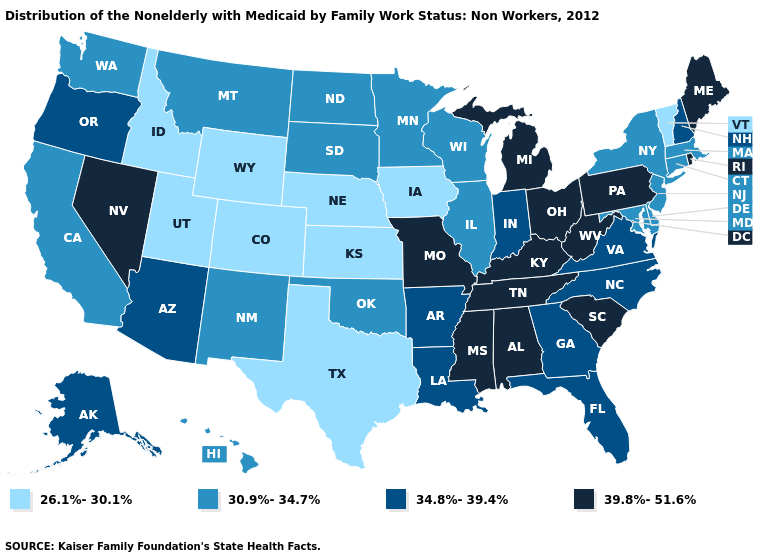Among the states that border Mississippi , which have the lowest value?
Short answer required. Arkansas, Louisiana. What is the value of Montana?
Be succinct. 30.9%-34.7%. Does Louisiana have a lower value than South Carolina?
Write a very short answer. Yes. Name the states that have a value in the range 34.8%-39.4%?
Be succinct. Alaska, Arizona, Arkansas, Florida, Georgia, Indiana, Louisiana, New Hampshire, North Carolina, Oregon, Virginia. Is the legend a continuous bar?
Be succinct. No. Which states hav the highest value in the West?
Be succinct. Nevada. Name the states that have a value in the range 26.1%-30.1%?
Concise answer only. Colorado, Idaho, Iowa, Kansas, Nebraska, Texas, Utah, Vermont, Wyoming. Name the states that have a value in the range 30.9%-34.7%?
Quick response, please. California, Connecticut, Delaware, Hawaii, Illinois, Maryland, Massachusetts, Minnesota, Montana, New Jersey, New Mexico, New York, North Dakota, Oklahoma, South Dakota, Washington, Wisconsin. What is the value of Connecticut?
Give a very brief answer. 30.9%-34.7%. What is the value of Kentucky?
Short answer required. 39.8%-51.6%. What is the highest value in states that border Mississippi?
Be succinct. 39.8%-51.6%. What is the lowest value in the MidWest?
Concise answer only. 26.1%-30.1%. What is the value of Pennsylvania?
Write a very short answer. 39.8%-51.6%. Does Kentucky have the highest value in the USA?
Short answer required. Yes. Name the states that have a value in the range 26.1%-30.1%?
Short answer required. Colorado, Idaho, Iowa, Kansas, Nebraska, Texas, Utah, Vermont, Wyoming. 